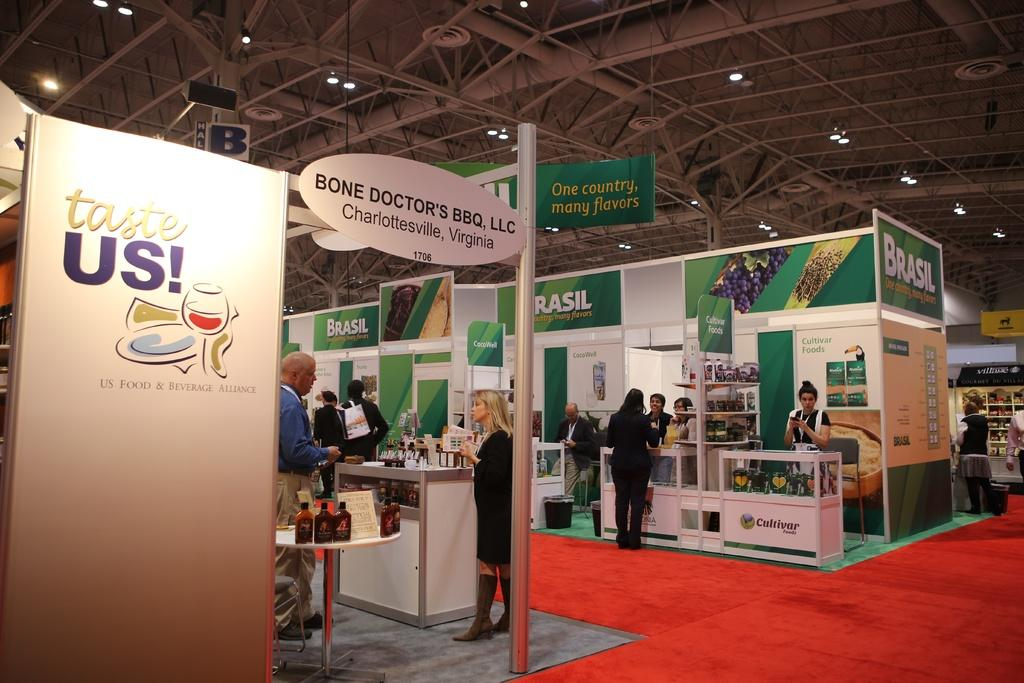<image>
Present a compact description of the photo's key features. People at a convention with a sign that says "Taste us!". 